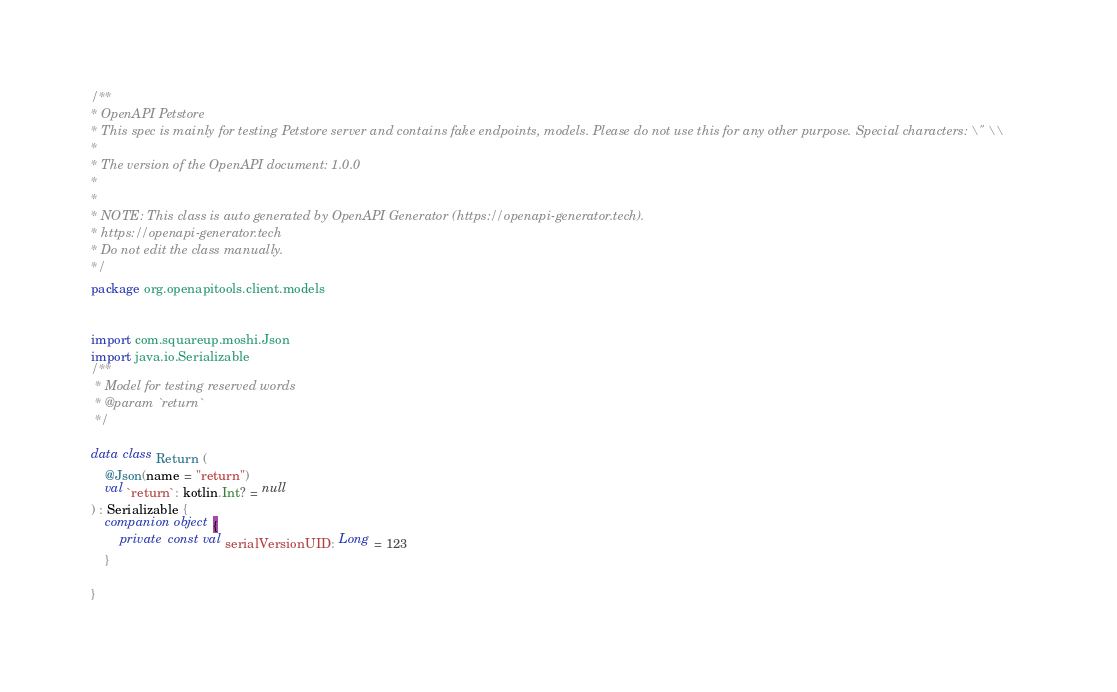Convert code to text. <code><loc_0><loc_0><loc_500><loc_500><_Kotlin_>/**
* OpenAPI Petstore
* This spec is mainly for testing Petstore server and contains fake endpoints, models. Please do not use this for any other purpose. Special characters: \" \\
*
* The version of the OpenAPI document: 1.0.0
* 
*
* NOTE: This class is auto generated by OpenAPI Generator (https://openapi-generator.tech).
* https://openapi-generator.tech
* Do not edit the class manually.
*/
package org.openapitools.client.models


import com.squareup.moshi.Json
import java.io.Serializable
/**
 * Model for testing reserved words
 * @param `return` 
 */

data class Return (
    @Json(name = "return")
    val `return`: kotlin.Int? = null
) : Serializable {
	companion object {
		private const val serialVersionUID: Long = 123
	}

}

</code> 